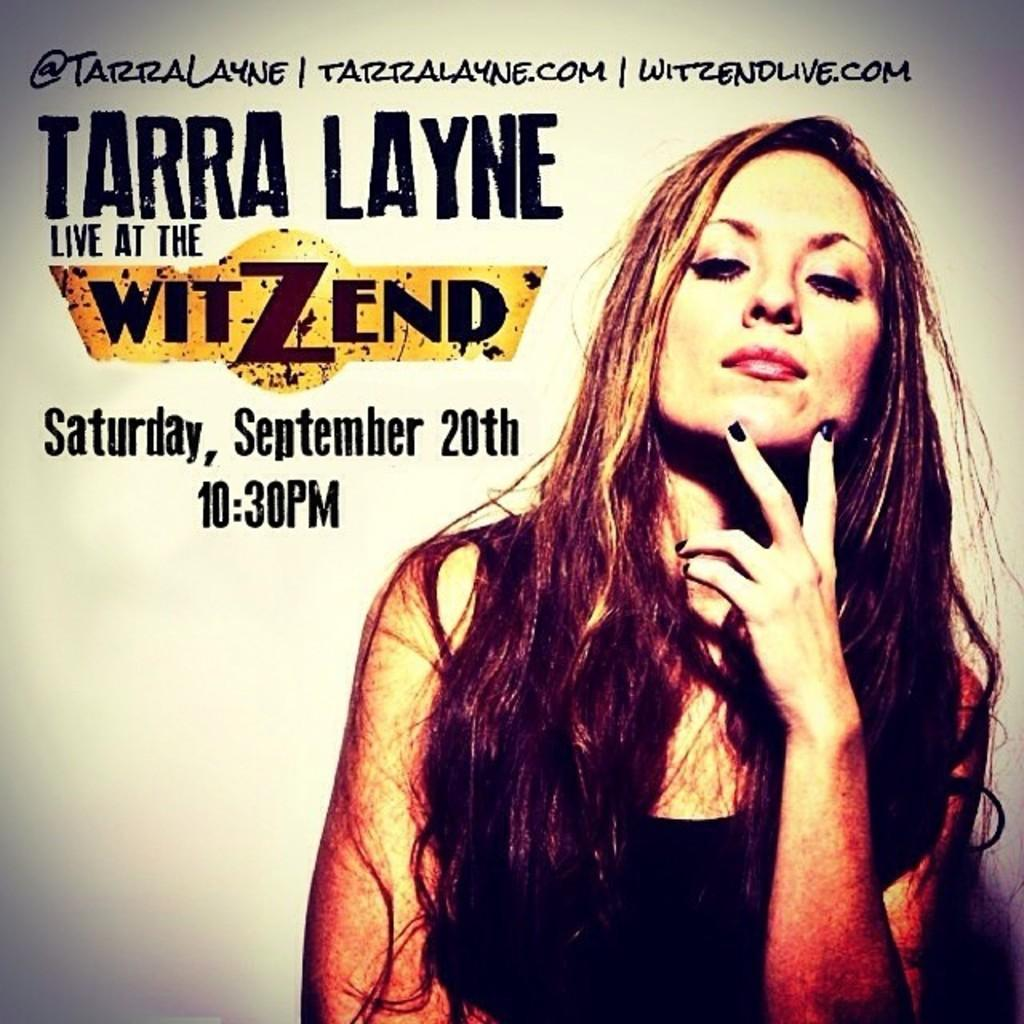What is present on the poster in the image? There is a poster in the image, which contains an image of a woman. What else can be seen on the poster besides the image of the woman? There is text on the poster. Where is the land located in the image? There is no land present in the image; it features a poster with an image of a woman and text. What type of shoe is the woman wearing in the image? There is no woman present in the image, nor is there any information about her attire. 